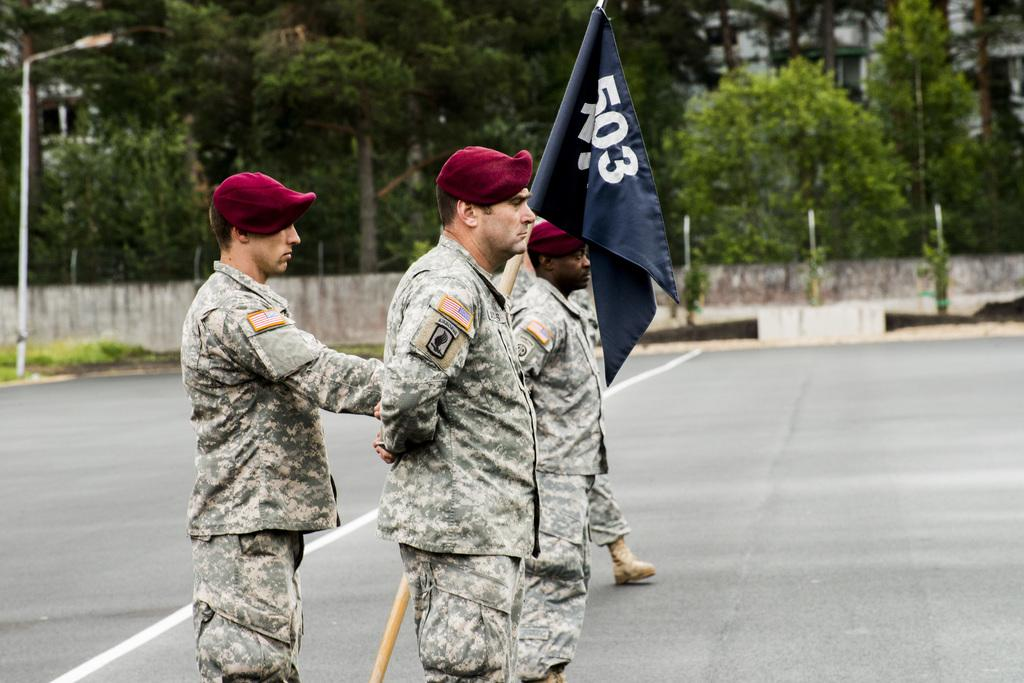What are the people in the image doing? The persons in the image are standing on the road. Can you describe any specific actions or objects held by the people? One of the persons is holding a flag. What can be seen in the background of the image? There is a utility pole and trees in the background of the image. What is the level of disgust expressed by the person holding the flag in the image? There is no indication of disgust in the image. What type of transport is being used by the people in the image? The image does not show any type of transport being used by the people. 